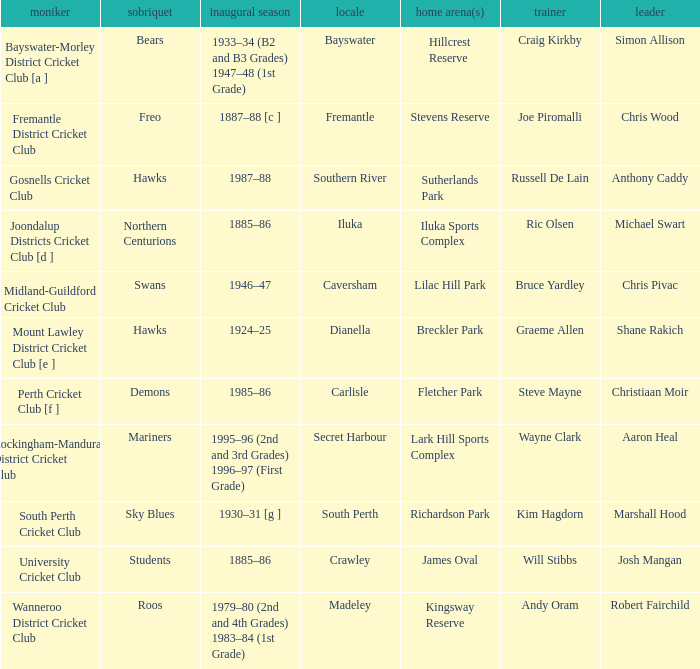Can you provide the name of the captain at the caversham site? Chris Pivac. 